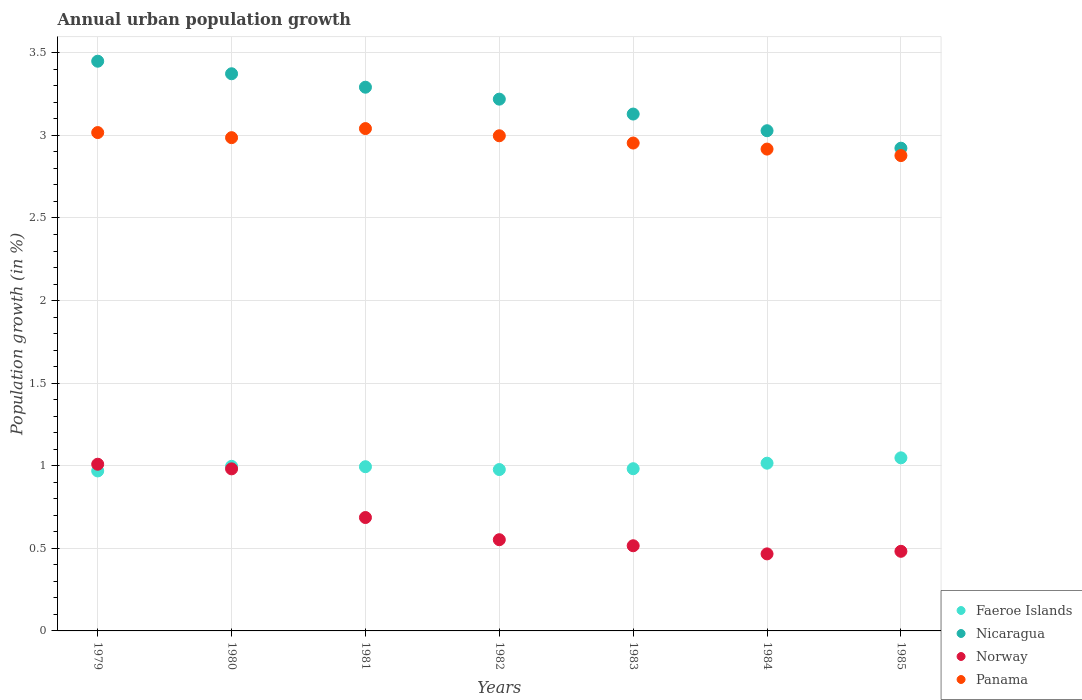What is the percentage of urban population growth in Faeroe Islands in 1979?
Your answer should be compact. 0.97. Across all years, what is the maximum percentage of urban population growth in Norway?
Your answer should be compact. 1.01. Across all years, what is the minimum percentage of urban population growth in Panama?
Offer a terse response. 2.88. In which year was the percentage of urban population growth in Norway minimum?
Provide a short and direct response. 1984. What is the total percentage of urban population growth in Faeroe Islands in the graph?
Keep it short and to the point. 6.98. What is the difference between the percentage of urban population growth in Norway in 1984 and that in 1985?
Your answer should be compact. -0.02. What is the difference between the percentage of urban population growth in Panama in 1985 and the percentage of urban population growth in Faeroe Islands in 1984?
Your answer should be compact. 1.86. What is the average percentage of urban population growth in Norway per year?
Keep it short and to the point. 0.67. In the year 1980, what is the difference between the percentage of urban population growth in Nicaragua and percentage of urban population growth in Panama?
Your answer should be very brief. 0.39. What is the ratio of the percentage of urban population growth in Panama in 1981 to that in 1983?
Provide a succinct answer. 1.03. What is the difference between the highest and the second highest percentage of urban population growth in Faeroe Islands?
Give a very brief answer. 0.03. What is the difference between the highest and the lowest percentage of urban population growth in Nicaragua?
Offer a very short reply. 0.53. Is it the case that in every year, the sum of the percentage of urban population growth in Faeroe Islands and percentage of urban population growth in Nicaragua  is greater than the percentage of urban population growth in Panama?
Your answer should be very brief. Yes. Does the percentage of urban population growth in Nicaragua monotonically increase over the years?
Keep it short and to the point. No. Is the percentage of urban population growth in Panama strictly less than the percentage of urban population growth in Faeroe Islands over the years?
Offer a very short reply. No. How many years are there in the graph?
Ensure brevity in your answer.  7. What is the difference between two consecutive major ticks on the Y-axis?
Offer a terse response. 0.5. Does the graph contain grids?
Offer a very short reply. Yes. Where does the legend appear in the graph?
Provide a succinct answer. Bottom right. How are the legend labels stacked?
Provide a short and direct response. Vertical. What is the title of the graph?
Offer a very short reply. Annual urban population growth. Does "Pakistan" appear as one of the legend labels in the graph?
Make the answer very short. No. What is the label or title of the Y-axis?
Make the answer very short. Population growth (in %). What is the Population growth (in %) of Faeroe Islands in 1979?
Offer a very short reply. 0.97. What is the Population growth (in %) of Nicaragua in 1979?
Your answer should be compact. 3.45. What is the Population growth (in %) in Norway in 1979?
Keep it short and to the point. 1.01. What is the Population growth (in %) of Panama in 1979?
Your answer should be very brief. 3.02. What is the Population growth (in %) of Faeroe Islands in 1980?
Provide a short and direct response. 1. What is the Population growth (in %) of Nicaragua in 1980?
Your answer should be compact. 3.37. What is the Population growth (in %) of Norway in 1980?
Provide a succinct answer. 0.98. What is the Population growth (in %) of Panama in 1980?
Ensure brevity in your answer.  2.99. What is the Population growth (in %) of Faeroe Islands in 1981?
Your answer should be very brief. 0.99. What is the Population growth (in %) of Nicaragua in 1981?
Your response must be concise. 3.29. What is the Population growth (in %) in Norway in 1981?
Provide a short and direct response. 0.69. What is the Population growth (in %) in Panama in 1981?
Your answer should be compact. 3.04. What is the Population growth (in %) in Faeroe Islands in 1982?
Your answer should be compact. 0.98. What is the Population growth (in %) of Nicaragua in 1982?
Make the answer very short. 3.22. What is the Population growth (in %) in Norway in 1982?
Your response must be concise. 0.55. What is the Population growth (in %) in Panama in 1982?
Offer a terse response. 3. What is the Population growth (in %) in Faeroe Islands in 1983?
Your answer should be very brief. 0.98. What is the Population growth (in %) in Nicaragua in 1983?
Offer a very short reply. 3.13. What is the Population growth (in %) in Norway in 1983?
Your response must be concise. 0.52. What is the Population growth (in %) in Panama in 1983?
Offer a terse response. 2.95. What is the Population growth (in %) of Faeroe Islands in 1984?
Offer a terse response. 1.02. What is the Population growth (in %) in Nicaragua in 1984?
Give a very brief answer. 3.03. What is the Population growth (in %) of Norway in 1984?
Your answer should be compact. 0.47. What is the Population growth (in %) in Panama in 1984?
Your response must be concise. 2.92. What is the Population growth (in %) in Faeroe Islands in 1985?
Provide a short and direct response. 1.05. What is the Population growth (in %) of Nicaragua in 1985?
Your answer should be very brief. 2.92. What is the Population growth (in %) of Norway in 1985?
Make the answer very short. 0.48. What is the Population growth (in %) in Panama in 1985?
Ensure brevity in your answer.  2.88. Across all years, what is the maximum Population growth (in %) of Faeroe Islands?
Keep it short and to the point. 1.05. Across all years, what is the maximum Population growth (in %) of Nicaragua?
Offer a terse response. 3.45. Across all years, what is the maximum Population growth (in %) of Norway?
Provide a succinct answer. 1.01. Across all years, what is the maximum Population growth (in %) of Panama?
Give a very brief answer. 3.04. Across all years, what is the minimum Population growth (in %) of Faeroe Islands?
Your answer should be very brief. 0.97. Across all years, what is the minimum Population growth (in %) in Nicaragua?
Ensure brevity in your answer.  2.92. Across all years, what is the minimum Population growth (in %) of Norway?
Give a very brief answer. 0.47. Across all years, what is the minimum Population growth (in %) of Panama?
Ensure brevity in your answer.  2.88. What is the total Population growth (in %) in Faeroe Islands in the graph?
Your answer should be very brief. 6.98. What is the total Population growth (in %) in Nicaragua in the graph?
Ensure brevity in your answer.  22.41. What is the total Population growth (in %) in Norway in the graph?
Give a very brief answer. 4.69. What is the total Population growth (in %) in Panama in the graph?
Offer a terse response. 20.79. What is the difference between the Population growth (in %) of Faeroe Islands in 1979 and that in 1980?
Provide a succinct answer. -0.03. What is the difference between the Population growth (in %) of Nicaragua in 1979 and that in 1980?
Ensure brevity in your answer.  0.08. What is the difference between the Population growth (in %) of Norway in 1979 and that in 1980?
Keep it short and to the point. 0.03. What is the difference between the Population growth (in %) in Panama in 1979 and that in 1980?
Offer a very short reply. 0.03. What is the difference between the Population growth (in %) in Faeroe Islands in 1979 and that in 1981?
Provide a short and direct response. -0.03. What is the difference between the Population growth (in %) of Nicaragua in 1979 and that in 1981?
Keep it short and to the point. 0.16. What is the difference between the Population growth (in %) of Norway in 1979 and that in 1981?
Ensure brevity in your answer.  0.32. What is the difference between the Population growth (in %) in Panama in 1979 and that in 1981?
Your answer should be very brief. -0.02. What is the difference between the Population growth (in %) in Faeroe Islands in 1979 and that in 1982?
Offer a very short reply. -0.01. What is the difference between the Population growth (in %) of Nicaragua in 1979 and that in 1982?
Your response must be concise. 0.23. What is the difference between the Population growth (in %) in Norway in 1979 and that in 1982?
Provide a succinct answer. 0.46. What is the difference between the Population growth (in %) of Panama in 1979 and that in 1982?
Keep it short and to the point. 0.02. What is the difference between the Population growth (in %) of Faeroe Islands in 1979 and that in 1983?
Provide a succinct answer. -0.01. What is the difference between the Population growth (in %) of Nicaragua in 1979 and that in 1983?
Ensure brevity in your answer.  0.32. What is the difference between the Population growth (in %) of Norway in 1979 and that in 1983?
Provide a short and direct response. 0.49. What is the difference between the Population growth (in %) in Panama in 1979 and that in 1983?
Ensure brevity in your answer.  0.06. What is the difference between the Population growth (in %) in Faeroe Islands in 1979 and that in 1984?
Offer a very short reply. -0.05. What is the difference between the Population growth (in %) of Nicaragua in 1979 and that in 1984?
Your answer should be very brief. 0.42. What is the difference between the Population growth (in %) of Norway in 1979 and that in 1984?
Your response must be concise. 0.54. What is the difference between the Population growth (in %) in Panama in 1979 and that in 1984?
Provide a short and direct response. 0.1. What is the difference between the Population growth (in %) in Faeroe Islands in 1979 and that in 1985?
Make the answer very short. -0.08. What is the difference between the Population growth (in %) of Nicaragua in 1979 and that in 1985?
Your answer should be compact. 0.53. What is the difference between the Population growth (in %) in Norway in 1979 and that in 1985?
Make the answer very short. 0.53. What is the difference between the Population growth (in %) of Panama in 1979 and that in 1985?
Provide a succinct answer. 0.14. What is the difference between the Population growth (in %) in Faeroe Islands in 1980 and that in 1981?
Your answer should be compact. 0. What is the difference between the Population growth (in %) of Nicaragua in 1980 and that in 1981?
Keep it short and to the point. 0.08. What is the difference between the Population growth (in %) in Norway in 1980 and that in 1981?
Provide a succinct answer. 0.29. What is the difference between the Population growth (in %) in Panama in 1980 and that in 1981?
Your answer should be very brief. -0.06. What is the difference between the Population growth (in %) in Faeroe Islands in 1980 and that in 1982?
Your answer should be very brief. 0.02. What is the difference between the Population growth (in %) in Nicaragua in 1980 and that in 1982?
Your answer should be very brief. 0.15. What is the difference between the Population growth (in %) of Norway in 1980 and that in 1982?
Keep it short and to the point. 0.43. What is the difference between the Population growth (in %) of Panama in 1980 and that in 1982?
Your response must be concise. -0.01. What is the difference between the Population growth (in %) in Faeroe Islands in 1980 and that in 1983?
Keep it short and to the point. 0.01. What is the difference between the Population growth (in %) in Nicaragua in 1980 and that in 1983?
Keep it short and to the point. 0.24. What is the difference between the Population growth (in %) in Norway in 1980 and that in 1983?
Your answer should be very brief. 0.47. What is the difference between the Population growth (in %) in Panama in 1980 and that in 1983?
Make the answer very short. 0.03. What is the difference between the Population growth (in %) of Faeroe Islands in 1980 and that in 1984?
Keep it short and to the point. -0.02. What is the difference between the Population growth (in %) in Nicaragua in 1980 and that in 1984?
Ensure brevity in your answer.  0.34. What is the difference between the Population growth (in %) in Norway in 1980 and that in 1984?
Your answer should be very brief. 0.51. What is the difference between the Population growth (in %) in Panama in 1980 and that in 1984?
Offer a terse response. 0.07. What is the difference between the Population growth (in %) in Faeroe Islands in 1980 and that in 1985?
Provide a succinct answer. -0.05. What is the difference between the Population growth (in %) of Nicaragua in 1980 and that in 1985?
Give a very brief answer. 0.45. What is the difference between the Population growth (in %) of Norway in 1980 and that in 1985?
Offer a very short reply. 0.5. What is the difference between the Population growth (in %) in Panama in 1980 and that in 1985?
Make the answer very short. 0.11. What is the difference between the Population growth (in %) in Faeroe Islands in 1981 and that in 1982?
Offer a terse response. 0.02. What is the difference between the Population growth (in %) in Nicaragua in 1981 and that in 1982?
Provide a short and direct response. 0.07. What is the difference between the Population growth (in %) of Norway in 1981 and that in 1982?
Offer a very short reply. 0.13. What is the difference between the Population growth (in %) of Panama in 1981 and that in 1982?
Provide a short and direct response. 0.04. What is the difference between the Population growth (in %) in Faeroe Islands in 1981 and that in 1983?
Offer a very short reply. 0.01. What is the difference between the Population growth (in %) in Nicaragua in 1981 and that in 1983?
Ensure brevity in your answer.  0.16. What is the difference between the Population growth (in %) in Norway in 1981 and that in 1983?
Keep it short and to the point. 0.17. What is the difference between the Population growth (in %) of Panama in 1981 and that in 1983?
Provide a short and direct response. 0.09. What is the difference between the Population growth (in %) in Faeroe Islands in 1981 and that in 1984?
Your response must be concise. -0.02. What is the difference between the Population growth (in %) of Nicaragua in 1981 and that in 1984?
Offer a very short reply. 0.26. What is the difference between the Population growth (in %) of Norway in 1981 and that in 1984?
Offer a terse response. 0.22. What is the difference between the Population growth (in %) of Panama in 1981 and that in 1984?
Provide a short and direct response. 0.12. What is the difference between the Population growth (in %) of Faeroe Islands in 1981 and that in 1985?
Your answer should be compact. -0.05. What is the difference between the Population growth (in %) in Nicaragua in 1981 and that in 1985?
Your answer should be compact. 0.37. What is the difference between the Population growth (in %) in Norway in 1981 and that in 1985?
Give a very brief answer. 0.2. What is the difference between the Population growth (in %) in Panama in 1981 and that in 1985?
Your answer should be compact. 0.16. What is the difference between the Population growth (in %) in Faeroe Islands in 1982 and that in 1983?
Your answer should be very brief. -0.01. What is the difference between the Population growth (in %) in Nicaragua in 1982 and that in 1983?
Offer a very short reply. 0.09. What is the difference between the Population growth (in %) of Norway in 1982 and that in 1983?
Ensure brevity in your answer.  0.04. What is the difference between the Population growth (in %) in Panama in 1982 and that in 1983?
Offer a very short reply. 0.04. What is the difference between the Population growth (in %) in Faeroe Islands in 1982 and that in 1984?
Provide a short and direct response. -0.04. What is the difference between the Population growth (in %) of Nicaragua in 1982 and that in 1984?
Offer a very short reply. 0.19. What is the difference between the Population growth (in %) in Norway in 1982 and that in 1984?
Offer a terse response. 0.09. What is the difference between the Population growth (in %) in Panama in 1982 and that in 1984?
Keep it short and to the point. 0.08. What is the difference between the Population growth (in %) in Faeroe Islands in 1982 and that in 1985?
Provide a succinct answer. -0.07. What is the difference between the Population growth (in %) in Nicaragua in 1982 and that in 1985?
Give a very brief answer. 0.3. What is the difference between the Population growth (in %) of Norway in 1982 and that in 1985?
Your response must be concise. 0.07. What is the difference between the Population growth (in %) in Panama in 1982 and that in 1985?
Your response must be concise. 0.12. What is the difference between the Population growth (in %) of Faeroe Islands in 1983 and that in 1984?
Give a very brief answer. -0.03. What is the difference between the Population growth (in %) of Nicaragua in 1983 and that in 1984?
Your response must be concise. 0.1. What is the difference between the Population growth (in %) of Norway in 1983 and that in 1984?
Offer a terse response. 0.05. What is the difference between the Population growth (in %) of Panama in 1983 and that in 1984?
Provide a succinct answer. 0.04. What is the difference between the Population growth (in %) of Faeroe Islands in 1983 and that in 1985?
Give a very brief answer. -0.07. What is the difference between the Population growth (in %) of Nicaragua in 1983 and that in 1985?
Ensure brevity in your answer.  0.21. What is the difference between the Population growth (in %) in Norway in 1983 and that in 1985?
Offer a terse response. 0.03. What is the difference between the Population growth (in %) in Panama in 1983 and that in 1985?
Provide a short and direct response. 0.08. What is the difference between the Population growth (in %) of Faeroe Islands in 1984 and that in 1985?
Your answer should be compact. -0.03. What is the difference between the Population growth (in %) in Nicaragua in 1984 and that in 1985?
Ensure brevity in your answer.  0.11. What is the difference between the Population growth (in %) in Norway in 1984 and that in 1985?
Your answer should be compact. -0.02. What is the difference between the Population growth (in %) in Panama in 1984 and that in 1985?
Provide a short and direct response. 0.04. What is the difference between the Population growth (in %) in Faeroe Islands in 1979 and the Population growth (in %) in Nicaragua in 1980?
Provide a succinct answer. -2.4. What is the difference between the Population growth (in %) in Faeroe Islands in 1979 and the Population growth (in %) in Norway in 1980?
Make the answer very short. -0.01. What is the difference between the Population growth (in %) of Faeroe Islands in 1979 and the Population growth (in %) of Panama in 1980?
Make the answer very short. -2.02. What is the difference between the Population growth (in %) of Nicaragua in 1979 and the Population growth (in %) of Norway in 1980?
Offer a terse response. 2.47. What is the difference between the Population growth (in %) of Nicaragua in 1979 and the Population growth (in %) of Panama in 1980?
Keep it short and to the point. 0.46. What is the difference between the Population growth (in %) in Norway in 1979 and the Population growth (in %) in Panama in 1980?
Give a very brief answer. -1.98. What is the difference between the Population growth (in %) of Faeroe Islands in 1979 and the Population growth (in %) of Nicaragua in 1981?
Your answer should be very brief. -2.32. What is the difference between the Population growth (in %) in Faeroe Islands in 1979 and the Population growth (in %) in Norway in 1981?
Ensure brevity in your answer.  0.28. What is the difference between the Population growth (in %) of Faeroe Islands in 1979 and the Population growth (in %) of Panama in 1981?
Provide a short and direct response. -2.07. What is the difference between the Population growth (in %) of Nicaragua in 1979 and the Population growth (in %) of Norway in 1981?
Give a very brief answer. 2.76. What is the difference between the Population growth (in %) of Nicaragua in 1979 and the Population growth (in %) of Panama in 1981?
Provide a succinct answer. 0.41. What is the difference between the Population growth (in %) in Norway in 1979 and the Population growth (in %) in Panama in 1981?
Your answer should be very brief. -2.03. What is the difference between the Population growth (in %) of Faeroe Islands in 1979 and the Population growth (in %) of Nicaragua in 1982?
Make the answer very short. -2.25. What is the difference between the Population growth (in %) in Faeroe Islands in 1979 and the Population growth (in %) in Norway in 1982?
Provide a succinct answer. 0.42. What is the difference between the Population growth (in %) of Faeroe Islands in 1979 and the Population growth (in %) of Panama in 1982?
Your response must be concise. -2.03. What is the difference between the Population growth (in %) in Nicaragua in 1979 and the Population growth (in %) in Norway in 1982?
Make the answer very short. 2.9. What is the difference between the Population growth (in %) of Nicaragua in 1979 and the Population growth (in %) of Panama in 1982?
Make the answer very short. 0.45. What is the difference between the Population growth (in %) of Norway in 1979 and the Population growth (in %) of Panama in 1982?
Your answer should be very brief. -1.99. What is the difference between the Population growth (in %) of Faeroe Islands in 1979 and the Population growth (in %) of Nicaragua in 1983?
Offer a terse response. -2.16. What is the difference between the Population growth (in %) of Faeroe Islands in 1979 and the Population growth (in %) of Norway in 1983?
Keep it short and to the point. 0.45. What is the difference between the Population growth (in %) in Faeroe Islands in 1979 and the Population growth (in %) in Panama in 1983?
Ensure brevity in your answer.  -1.99. What is the difference between the Population growth (in %) in Nicaragua in 1979 and the Population growth (in %) in Norway in 1983?
Offer a very short reply. 2.93. What is the difference between the Population growth (in %) of Nicaragua in 1979 and the Population growth (in %) of Panama in 1983?
Make the answer very short. 0.5. What is the difference between the Population growth (in %) of Norway in 1979 and the Population growth (in %) of Panama in 1983?
Provide a succinct answer. -1.94. What is the difference between the Population growth (in %) in Faeroe Islands in 1979 and the Population growth (in %) in Nicaragua in 1984?
Provide a succinct answer. -2.06. What is the difference between the Population growth (in %) of Faeroe Islands in 1979 and the Population growth (in %) of Norway in 1984?
Your answer should be very brief. 0.5. What is the difference between the Population growth (in %) in Faeroe Islands in 1979 and the Population growth (in %) in Panama in 1984?
Your answer should be very brief. -1.95. What is the difference between the Population growth (in %) of Nicaragua in 1979 and the Population growth (in %) of Norway in 1984?
Provide a short and direct response. 2.98. What is the difference between the Population growth (in %) in Nicaragua in 1979 and the Population growth (in %) in Panama in 1984?
Ensure brevity in your answer.  0.53. What is the difference between the Population growth (in %) in Norway in 1979 and the Population growth (in %) in Panama in 1984?
Your response must be concise. -1.91. What is the difference between the Population growth (in %) of Faeroe Islands in 1979 and the Population growth (in %) of Nicaragua in 1985?
Offer a very short reply. -1.95. What is the difference between the Population growth (in %) of Faeroe Islands in 1979 and the Population growth (in %) of Norway in 1985?
Provide a succinct answer. 0.49. What is the difference between the Population growth (in %) of Faeroe Islands in 1979 and the Population growth (in %) of Panama in 1985?
Ensure brevity in your answer.  -1.91. What is the difference between the Population growth (in %) of Nicaragua in 1979 and the Population growth (in %) of Norway in 1985?
Provide a succinct answer. 2.97. What is the difference between the Population growth (in %) in Nicaragua in 1979 and the Population growth (in %) in Panama in 1985?
Give a very brief answer. 0.57. What is the difference between the Population growth (in %) of Norway in 1979 and the Population growth (in %) of Panama in 1985?
Your answer should be compact. -1.87. What is the difference between the Population growth (in %) in Faeroe Islands in 1980 and the Population growth (in %) in Nicaragua in 1981?
Give a very brief answer. -2.3. What is the difference between the Population growth (in %) in Faeroe Islands in 1980 and the Population growth (in %) in Norway in 1981?
Your response must be concise. 0.31. What is the difference between the Population growth (in %) in Faeroe Islands in 1980 and the Population growth (in %) in Panama in 1981?
Your answer should be compact. -2.04. What is the difference between the Population growth (in %) of Nicaragua in 1980 and the Population growth (in %) of Norway in 1981?
Your answer should be very brief. 2.69. What is the difference between the Population growth (in %) of Nicaragua in 1980 and the Population growth (in %) of Panama in 1981?
Keep it short and to the point. 0.33. What is the difference between the Population growth (in %) of Norway in 1980 and the Population growth (in %) of Panama in 1981?
Your response must be concise. -2.06. What is the difference between the Population growth (in %) in Faeroe Islands in 1980 and the Population growth (in %) in Nicaragua in 1982?
Your response must be concise. -2.22. What is the difference between the Population growth (in %) of Faeroe Islands in 1980 and the Population growth (in %) of Norway in 1982?
Keep it short and to the point. 0.44. What is the difference between the Population growth (in %) in Faeroe Islands in 1980 and the Population growth (in %) in Panama in 1982?
Your answer should be compact. -2. What is the difference between the Population growth (in %) in Nicaragua in 1980 and the Population growth (in %) in Norway in 1982?
Offer a very short reply. 2.82. What is the difference between the Population growth (in %) of Nicaragua in 1980 and the Population growth (in %) of Panama in 1982?
Provide a succinct answer. 0.38. What is the difference between the Population growth (in %) in Norway in 1980 and the Population growth (in %) in Panama in 1982?
Keep it short and to the point. -2.02. What is the difference between the Population growth (in %) in Faeroe Islands in 1980 and the Population growth (in %) in Nicaragua in 1983?
Give a very brief answer. -2.13. What is the difference between the Population growth (in %) of Faeroe Islands in 1980 and the Population growth (in %) of Norway in 1983?
Provide a succinct answer. 0.48. What is the difference between the Population growth (in %) of Faeroe Islands in 1980 and the Population growth (in %) of Panama in 1983?
Provide a short and direct response. -1.96. What is the difference between the Population growth (in %) in Nicaragua in 1980 and the Population growth (in %) in Norway in 1983?
Ensure brevity in your answer.  2.86. What is the difference between the Population growth (in %) of Nicaragua in 1980 and the Population growth (in %) of Panama in 1983?
Your answer should be very brief. 0.42. What is the difference between the Population growth (in %) of Norway in 1980 and the Population growth (in %) of Panama in 1983?
Provide a succinct answer. -1.97. What is the difference between the Population growth (in %) of Faeroe Islands in 1980 and the Population growth (in %) of Nicaragua in 1984?
Keep it short and to the point. -2.03. What is the difference between the Population growth (in %) of Faeroe Islands in 1980 and the Population growth (in %) of Norway in 1984?
Provide a short and direct response. 0.53. What is the difference between the Population growth (in %) in Faeroe Islands in 1980 and the Population growth (in %) in Panama in 1984?
Provide a succinct answer. -1.92. What is the difference between the Population growth (in %) in Nicaragua in 1980 and the Population growth (in %) in Norway in 1984?
Offer a very short reply. 2.91. What is the difference between the Population growth (in %) of Nicaragua in 1980 and the Population growth (in %) of Panama in 1984?
Keep it short and to the point. 0.46. What is the difference between the Population growth (in %) of Norway in 1980 and the Population growth (in %) of Panama in 1984?
Offer a very short reply. -1.94. What is the difference between the Population growth (in %) of Faeroe Islands in 1980 and the Population growth (in %) of Nicaragua in 1985?
Your answer should be very brief. -1.93. What is the difference between the Population growth (in %) in Faeroe Islands in 1980 and the Population growth (in %) in Norway in 1985?
Ensure brevity in your answer.  0.51. What is the difference between the Population growth (in %) of Faeroe Islands in 1980 and the Population growth (in %) of Panama in 1985?
Your answer should be very brief. -1.88. What is the difference between the Population growth (in %) of Nicaragua in 1980 and the Population growth (in %) of Norway in 1985?
Provide a succinct answer. 2.89. What is the difference between the Population growth (in %) of Nicaragua in 1980 and the Population growth (in %) of Panama in 1985?
Your answer should be very brief. 0.5. What is the difference between the Population growth (in %) of Norway in 1980 and the Population growth (in %) of Panama in 1985?
Offer a very short reply. -1.9. What is the difference between the Population growth (in %) of Faeroe Islands in 1981 and the Population growth (in %) of Nicaragua in 1982?
Provide a short and direct response. -2.23. What is the difference between the Population growth (in %) of Faeroe Islands in 1981 and the Population growth (in %) of Norway in 1982?
Keep it short and to the point. 0.44. What is the difference between the Population growth (in %) of Faeroe Islands in 1981 and the Population growth (in %) of Panama in 1982?
Offer a terse response. -2. What is the difference between the Population growth (in %) of Nicaragua in 1981 and the Population growth (in %) of Norway in 1982?
Keep it short and to the point. 2.74. What is the difference between the Population growth (in %) in Nicaragua in 1981 and the Population growth (in %) in Panama in 1982?
Your answer should be very brief. 0.29. What is the difference between the Population growth (in %) of Norway in 1981 and the Population growth (in %) of Panama in 1982?
Your response must be concise. -2.31. What is the difference between the Population growth (in %) in Faeroe Islands in 1981 and the Population growth (in %) in Nicaragua in 1983?
Give a very brief answer. -2.13. What is the difference between the Population growth (in %) of Faeroe Islands in 1981 and the Population growth (in %) of Norway in 1983?
Make the answer very short. 0.48. What is the difference between the Population growth (in %) of Faeroe Islands in 1981 and the Population growth (in %) of Panama in 1983?
Provide a succinct answer. -1.96. What is the difference between the Population growth (in %) in Nicaragua in 1981 and the Population growth (in %) in Norway in 1983?
Provide a short and direct response. 2.78. What is the difference between the Population growth (in %) in Nicaragua in 1981 and the Population growth (in %) in Panama in 1983?
Your answer should be very brief. 0.34. What is the difference between the Population growth (in %) in Norway in 1981 and the Population growth (in %) in Panama in 1983?
Offer a terse response. -2.27. What is the difference between the Population growth (in %) in Faeroe Islands in 1981 and the Population growth (in %) in Nicaragua in 1984?
Offer a terse response. -2.03. What is the difference between the Population growth (in %) in Faeroe Islands in 1981 and the Population growth (in %) in Norway in 1984?
Provide a succinct answer. 0.53. What is the difference between the Population growth (in %) in Faeroe Islands in 1981 and the Population growth (in %) in Panama in 1984?
Keep it short and to the point. -1.92. What is the difference between the Population growth (in %) of Nicaragua in 1981 and the Population growth (in %) of Norway in 1984?
Make the answer very short. 2.83. What is the difference between the Population growth (in %) in Nicaragua in 1981 and the Population growth (in %) in Panama in 1984?
Give a very brief answer. 0.37. What is the difference between the Population growth (in %) in Norway in 1981 and the Population growth (in %) in Panama in 1984?
Provide a succinct answer. -2.23. What is the difference between the Population growth (in %) in Faeroe Islands in 1981 and the Population growth (in %) in Nicaragua in 1985?
Offer a very short reply. -1.93. What is the difference between the Population growth (in %) of Faeroe Islands in 1981 and the Population growth (in %) of Norway in 1985?
Offer a very short reply. 0.51. What is the difference between the Population growth (in %) in Faeroe Islands in 1981 and the Population growth (in %) in Panama in 1985?
Offer a terse response. -1.88. What is the difference between the Population growth (in %) in Nicaragua in 1981 and the Population growth (in %) in Norway in 1985?
Make the answer very short. 2.81. What is the difference between the Population growth (in %) in Nicaragua in 1981 and the Population growth (in %) in Panama in 1985?
Offer a terse response. 0.41. What is the difference between the Population growth (in %) in Norway in 1981 and the Population growth (in %) in Panama in 1985?
Provide a short and direct response. -2.19. What is the difference between the Population growth (in %) of Faeroe Islands in 1982 and the Population growth (in %) of Nicaragua in 1983?
Offer a very short reply. -2.15. What is the difference between the Population growth (in %) in Faeroe Islands in 1982 and the Population growth (in %) in Norway in 1983?
Make the answer very short. 0.46. What is the difference between the Population growth (in %) in Faeroe Islands in 1982 and the Population growth (in %) in Panama in 1983?
Your response must be concise. -1.98. What is the difference between the Population growth (in %) in Nicaragua in 1982 and the Population growth (in %) in Norway in 1983?
Make the answer very short. 2.7. What is the difference between the Population growth (in %) in Nicaragua in 1982 and the Population growth (in %) in Panama in 1983?
Your response must be concise. 0.27. What is the difference between the Population growth (in %) in Norway in 1982 and the Population growth (in %) in Panama in 1983?
Your response must be concise. -2.4. What is the difference between the Population growth (in %) in Faeroe Islands in 1982 and the Population growth (in %) in Nicaragua in 1984?
Your answer should be compact. -2.05. What is the difference between the Population growth (in %) in Faeroe Islands in 1982 and the Population growth (in %) in Norway in 1984?
Offer a terse response. 0.51. What is the difference between the Population growth (in %) in Faeroe Islands in 1982 and the Population growth (in %) in Panama in 1984?
Your response must be concise. -1.94. What is the difference between the Population growth (in %) of Nicaragua in 1982 and the Population growth (in %) of Norway in 1984?
Offer a terse response. 2.75. What is the difference between the Population growth (in %) in Nicaragua in 1982 and the Population growth (in %) in Panama in 1984?
Your response must be concise. 0.3. What is the difference between the Population growth (in %) in Norway in 1982 and the Population growth (in %) in Panama in 1984?
Make the answer very short. -2.36. What is the difference between the Population growth (in %) of Faeroe Islands in 1982 and the Population growth (in %) of Nicaragua in 1985?
Ensure brevity in your answer.  -1.95. What is the difference between the Population growth (in %) in Faeroe Islands in 1982 and the Population growth (in %) in Norway in 1985?
Your response must be concise. 0.49. What is the difference between the Population growth (in %) in Faeroe Islands in 1982 and the Population growth (in %) in Panama in 1985?
Give a very brief answer. -1.9. What is the difference between the Population growth (in %) of Nicaragua in 1982 and the Population growth (in %) of Norway in 1985?
Give a very brief answer. 2.74. What is the difference between the Population growth (in %) in Nicaragua in 1982 and the Population growth (in %) in Panama in 1985?
Your answer should be compact. 0.34. What is the difference between the Population growth (in %) of Norway in 1982 and the Population growth (in %) of Panama in 1985?
Ensure brevity in your answer.  -2.33. What is the difference between the Population growth (in %) in Faeroe Islands in 1983 and the Population growth (in %) in Nicaragua in 1984?
Make the answer very short. -2.05. What is the difference between the Population growth (in %) in Faeroe Islands in 1983 and the Population growth (in %) in Norway in 1984?
Keep it short and to the point. 0.52. What is the difference between the Population growth (in %) in Faeroe Islands in 1983 and the Population growth (in %) in Panama in 1984?
Your answer should be very brief. -1.94. What is the difference between the Population growth (in %) in Nicaragua in 1983 and the Population growth (in %) in Norway in 1984?
Provide a short and direct response. 2.66. What is the difference between the Population growth (in %) of Nicaragua in 1983 and the Population growth (in %) of Panama in 1984?
Your answer should be compact. 0.21. What is the difference between the Population growth (in %) of Norway in 1983 and the Population growth (in %) of Panama in 1984?
Your response must be concise. -2.4. What is the difference between the Population growth (in %) in Faeroe Islands in 1983 and the Population growth (in %) in Nicaragua in 1985?
Provide a succinct answer. -1.94. What is the difference between the Population growth (in %) in Faeroe Islands in 1983 and the Population growth (in %) in Norway in 1985?
Provide a short and direct response. 0.5. What is the difference between the Population growth (in %) in Faeroe Islands in 1983 and the Population growth (in %) in Panama in 1985?
Offer a terse response. -1.9. What is the difference between the Population growth (in %) of Nicaragua in 1983 and the Population growth (in %) of Norway in 1985?
Your response must be concise. 2.65. What is the difference between the Population growth (in %) in Nicaragua in 1983 and the Population growth (in %) in Panama in 1985?
Offer a very short reply. 0.25. What is the difference between the Population growth (in %) in Norway in 1983 and the Population growth (in %) in Panama in 1985?
Make the answer very short. -2.36. What is the difference between the Population growth (in %) in Faeroe Islands in 1984 and the Population growth (in %) in Nicaragua in 1985?
Keep it short and to the point. -1.91. What is the difference between the Population growth (in %) in Faeroe Islands in 1984 and the Population growth (in %) in Norway in 1985?
Your answer should be very brief. 0.53. What is the difference between the Population growth (in %) in Faeroe Islands in 1984 and the Population growth (in %) in Panama in 1985?
Keep it short and to the point. -1.86. What is the difference between the Population growth (in %) in Nicaragua in 1984 and the Population growth (in %) in Norway in 1985?
Your answer should be compact. 2.55. What is the difference between the Population growth (in %) in Nicaragua in 1984 and the Population growth (in %) in Panama in 1985?
Offer a terse response. 0.15. What is the difference between the Population growth (in %) of Norway in 1984 and the Population growth (in %) of Panama in 1985?
Make the answer very short. -2.41. What is the average Population growth (in %) in Faeroe Islands per year?
Keep it short and to the point. 1. What is the average Population growth (in %) in Nicaragua per year?
Make the answer very short. 3.2. What is the average Population growth (in %) in Norway per year?
Provide a short and direct response. 0.67. What is the average Population growth (in %) in Panama per year?
Ensure brevity in your answer.  2.97. In the year 1979, what is the difference between the Population growth (in %) in Faeroe Islands and Population growth (in %) in Nicaragua?
Provide a short and direct response. -2.48. In the year 1979, what is the difference between the Population growth (in %) of Faeroe Islands and Population growth (in %) of Norway?
Offer a terse response. -0.04. In the year 1979, what is the difference between the Population growth (in %) of Faeroe Islands and Population growth (in %) of Panama?
Offer a very short reply. -2.05. In the year 1979, what is the difference between the Population growth (in %) in Nicaragua and Population growth (in %) in Norway?
Your response must be concise. 2.44. In the year 1979, what is the difference between the Population growth (in %) in Nicaragua and Population growth (in %) in Panama?
Offer a terse response. 0.43. In the year 1979, what is the difference between the Population growth (in %) of Norway and Population growth (in %) of Panama?
Your answer should be compact. -2.01. In the year 1980, what is the difference between the Population growth (in %) of Faeroe Islands and Population growth (in %) of Nicaragua?
Your answer should be compact. -2.38. In the year 1980, what is the difference between the Population growth (in %) of Faeroe Islands and Population growth (in %) of Norway?
Provide a succinct answer. 0.02. In the year 1980, what is the difference between the Population growth (in %) in Faeroe Islands and Population growth (in %) in Panama?
Offer a very short reply. -1.99. In the year 1980, what is the difference between the Population growth (in %) in Nicaragua and Population growth (in %) in Norway?
Your response must be concise. 2.39. In the year 1980, what is the difference between the Population growth (in %) in Nicaragua and Population growth (in %) in Panama?
Offer a terse response. 0.39. In the year 1980, what is the difference between the Population growth (in %) of Norway and Population growth (in %) of Panama?
Your response must be concise. -2. In the year 1981, what is the difference between the Population growth (in %) of Faeroe Islands and Population growth (in %) of Nicaragua?
Your answer should be compact. -2.3. In the year 1981, what is the difference between the Population growth (in %) in Faeroe Islands and Population growth (in %) in Norway?
Give a very brief answer. 0.31. In the year 1981, what is the difference between the Population growth (in %) of Faeroe Islands and Population growth (in %) of Panama?
Provide a short and direct response. -2.05. In the year 1981, what is the difference between the Population growth (in %) in Nicaragua and Population growth (in %) in Norway?
Provide a short and direct response. 2.61. In the year 1981, what is the difference between the Population growth (in %) of Nicaragua and Population growth (in %) of Panama?
Offer a terse response. 0.25. In the year 1981, what is the difference between the Population growth (in %) in Norway and Population growth (in %) in Panama?
Offer a terse response. -2.35. In the year 1982, what is the difference between the Population growth (in %) of Faeroe Islands and Population growth (in %) of Nicaragua?
Ensure brevity in your answer.  -2.24. In the year 1982, what is the difference between the Population growth (in %) in Faeroe Islands and Population growth (in %) in Norway?
Give a very brief answer. 0.42. In the year 1982, what is the difference between the Population growth (in %) in Faeroe Islands and Population growth (in %) in Panama?
Offer a terse response. -2.02. In the year 1982, what is the difference between the Population growth (in %) of Nicaragua and Population growth (in %) of Norway?
Your answer should be compact. 2.67. In the year 1982, what is the difference between the Population growth (in %) of Nicaragua and Population growth (in %) of Panama?
Provide a succinct answer. 0.22. In the year 1982, what is the difference between the Population growth (in %) of Norway and Population growth (in %) of Panama?
Your answer should be very brief. -2.45. In the year 1983, what is the difference between the Population growth (in %) in Faeroe Islands and Population growth (in %) in Nicaragua?
Your answer should be compact. -2.15. In the year 1983, what is the difference between the Population growth (in %) in Faeroe Islands and Population growth (in %) in Norway?
Keep it short and to the point. 0.47. In the year 1983, what is the difference between the Population growth (in %) in Faeroe Islands and Population growth (in %) in Panama?
Provide a succinct answer. -1.97. In the year 1983, what is the difference between the Population growth (in %) of Nicaragua and Population growth (in %) of Norway?
Provide a short and direct response. 2.61. In the year 1983, what is the difference between the Population growth (in %) in Nicaragua and Population growth (in %) in Panama?
Your response must be concise. 0.18. In the year 1983, what is the difference between the Population growth (in %) of Norway and Population growth (in %) of Panama?
Provide a succinct answer. -2.44. In the year 1984, what is the difference between the Population growth (in %) in Faeroe Islands and Population growth (in %) in Nicaragua?
Give a very brief answer. -2.01. In the year 1984, what is the difference between the Population growth (in %) of Faeroe Islands and Population growth (in %) of Norway?
Your answer should be very brief. 0.55. In the year 1984, what is the difference between the Population growth (in %) of Faeroe Islands and Population growth (in %) of Panama?
Provide a short and direct response. -1.9. In the year 1984, what is the difference between the Population growth (in %) in Nicaragua and Population growth (in %) in Norway?
Your answer should be very brief. 2.56. In the year 1984, what is the difference between the Population growth (in %) of Nicaragua and Population growth (in %) of Panama?
Your answer should be very brief. 0.11. In the year 1984, what is the difference between the Population growth (in %) in Norway and Population growth (in %) in Panama?
Give a very brief answer. -2.45. In the year 1985, what is the difference between the Population growth (in %) of Faeroe Islands and Population growth (in %) of Nicaragua?
Offer a terse response. -1.87. In the year 1985, what is the difference between the Population growth (in %) in Faeroe Islands and Population growth (in %) in Norway?
Offer a very short reply. 0.57. In the year 1985, what is the difference between the Population growth (in %) in Faeroe Islands and Population growth (in %) in Panama?
Keep it short and to the point. -1.83. In the year 1985, what is the difference between the Population growth (in %) of Nicaragua and Population growth (in %) of Norway?
Offer a very short reply. 2.44. In the year 1985, what is the difference between the Population growth (in %) in Nicaragua and Population growth (in %) in Panama?
Provide a short and direct response. 0.04. In the year 1985, what is the difference between the Population growth (in %) in Norway and Population growth (in %) in Panama?
Your response must be concise. -2.4. What is the ratio of the Population growth (in %) in Faeroe Islands in 1979 to that in 1980?
Give a very brief answer. 0.97. What is the ratio of the Population growth (in %) in Nicaragua in 1979 to that in 1980?
Give a very brief answer. 1.02. What is the ratio of the Population growth (in %) in Norway in 1979 to that in 1980?
Your answer should be very brief. 1.03. What is the ratio of the Population growth (in %) in Panama in 1979 to that in 1980?
Provide a succinct answer. 1.01. What is the ratio of the Population growth (in %) of Faeroe Islands in 1979 to that in 1981?
Ensure brevity in your answer.  0.97. What is the ratio of the Population growth (in %) of Nicaragua in 1979 to that in 1981?
Keep it short and to the point. 1.05. What is the ratio of the Population growth (in %) in Norway in 1979 to that in 1981?
Ensure brevity in your answer.  1.47. What is the ratio of the Population growth (in %) in Nicaragua in 1979 to that in 1982?
Your response must be concise. 1.07. What is the ratio of the Population growth (in %) of Norway in 1979 to that in 1982?
Ensure brevity in your answer.  1.83. What is the ratio of the Population growth (in %) in Panama in 1979 to that in 1982?
Offer a very short reply. 1.01. What is the ratio of the Population growth (in %) in Faeroe Islands in 1979 to that in 1983?
Offer a terse response. 0.99. What is the ratio of the Population growth (in %) in Nicaragua in 1979 to that in 1983?
Keep it short and to the point. 1.1. What is the ratio of the Population growth (in %) in Norway in 1979 to that in 1983?
Ensure brevity in your answer.  1.96. What is the ratio of the Population growth (in %) of Panama in 1979 to that in 1983?
Offer a very short reply. 1.02. What is the ratio of the Population growth (in %) of Faeroe Islands in 1979 to that in 1984?
Offer a very short reply. 0.95. What is the ratio of the Population growth (in %) in Nicaragua in 1979 to that in 1984?
Your response must be concise. 1.14. What is the ratio of the Population growth (in %) of Norway in 1979 to that in 1984?
Your answer should be very brief. 2.16. What is the ratio of the Population growth (in %) in Panama in 1979 to that in 1984?
Your response must be concise. 1.03. What is the ratio of the Population growth (in %) in Faeroe Islands in 1979 to that in 1985?
Provide a succinct answer. 0.92. What is the ratio of the Population growth (in %) of Nicaragua in 1979 to that in 1985?
Keep it short and to the point. 1.18. What is the ratio of the Population growth (in %) of Norway in 1979 to that in 1985?
Provide a succinct answer. 2.09. What is the ratio of the Population growth (in %) in Panama in 1979 to that in 1985?
Your answer should be compact. 1.05. What is the ratio of the Population growth (in %) of Nicaragua in 1980 to that in 1981?
Provide a short and direct response. 1.02. What is the ratio of the Population growth (in %) in Norway in 1980 to that in 1981?
Offer a very short reply. 1.43. What is the ratio of the Population growth (in %) in Panama in 1980 to that in 1981?
Your answer should be very brief. 0.98. What is the ratio of the Population growth (in %) of Faeroe Islands in 1980 to that in 1982?
Your answer should be very brief. 1.02. What is the ratio of the Population growth (in %) of Nicaragua in 1980 to that in 1982?
Give a very brief answer. 1.05. What is the ratio of the Population growth (in %) of Norway in 1980 to that in 1982?
Provide a succinct answer. 1.78. What is the ratio of the Population growth (in %) in Panama in 1980 to that in 1982?
Provide a short and direct response. 1. What is the ratio of the Population growth (in %) in Faeroe Islands in 1980 to that in 1983?
Offer a very short reply. 1.01. What is the ratio of the Population growth (in %) in Nicaragua in 1980 to that in 1983?
Your response must be concise. 1.08. What is the ratio of the Population growth (in %) in Norway in 1980 to that in 1983?
Your answer should be compact. 1.9. What is the ratio of the Population growth (in %) in Faeroe Islands in 1980 to that in 1984?
Keep it short and to the point. 0.98. What is the ratio of the Population growth (in %) of Nicaragua in 1980 to that in 1984?
Your answer should be compact. 1.11. What is the ratio of the Population growth (in %) of Norway in 1980 to that in 1984?
Your response must be concise. 2.1. What is the ratio of the Population growth (in %) in Panama in 1980 to that in 1984?
Make the answer very short. 1.02. What is the ratio of the Population growth (in %) of Faeroe Islands in 1980 to that in 1985?
Make the answer very short. 0.95. What is the ratio of the Population growth (in %) of Nicaragua in 1980 to that in 1985?
Keep it short and to the point. 1.15. What is the ratio of the Population growth (in %) in Norway in 1980 to that in 1985?
Your answer should be compact. 2.04. What is the ratio of the Population growth (in %) in Panama in 1980 to that in 1985?
Your answer should be compact. 1.04. What is the ratio of the Population growth (in %) of Faeroe Islands in 1981 to that in 1982?
Your answer should be very brief. 1.02. What is the ratio of the Population growth (in %) in Nicaragua in 1981 to that in 1982?
Your response must be concise. 1.02. What is the ratio of the Population growth (in %) of Norway in 1981 to that in 1982?
Provide a succinct answer. 1.24. What is the ratio of the Population growth (in %) of Panama in 1981 to that in 1982?
Provide a short and direct response. 1.01. What is the ratio of the Population growth (in %) in Faeroe Islands in 1981 to that in 1983?
Your answer should be compact. 1.01. What is the ratio of the Population growth (in %) in Nicaragua in 1981 to that in 1983?
Make the answer very short. 1.05. What is the ratio of the Population growth (in %) in Norway in 1981 to that in 1983?
Ensure brevity in your answer.  1.33. What is the ratio of the Population growth (in %) in Panama in 1981 to that in 1983?
Ensure brevity in your answer.  1.03. What is the ratio of the Population growth (in %) in Faeroe Islands in 1981 to that in 1984?
Offer a very short reply. 0.98. What is the ratio of the Population growth (in %) of Nicaragua in 1981 to that in 1984?
Offer a terse response. 1.09. What is the ratio of the Population growth (in %) in Norway in 1981 to that in 1984?
Give a very brief answer. 1.47. What is the ratio of the Population growth (in %) of Panama in 1981 to that in 1984?
Your answer should be very brief. 1.04. What is the ratio of the Population growth (in %) in Faeroe Islands in 1981 to that in 1985?
Keep it short and to the point. 0.95. What is the ratio of the Population growth (in %) of Nicaragua in 1981 to that in 1985?
Offer a terse response. 1.13. What is the ratio of the Population growth (in %) in Norway in 1981 to that in 1985?
Ensure brevity in your answer.  1.42. What is the ratio of the Population growth (in %) in Panama in 1981 to that in 1985?
Your answer should be very brief. 1.06. What is the ratio of the Population growth (in %) in Nicaragua in 1982 to that in 1983?
Provide a succinct answer. 1.03. What is the ratio of the Population growth (in %) in Norway in 1982 to that in 1983?
Keep it short and to the point. 1.07. What is the ratio of the Population growth (in %) of Panama in 1982 to that in 1983?
Your answer should be compact. 1.01. What is the ratio of the Population growth (in %) of Faeroe Islands in 1982 to that in 1984?
Offer a very short reply. 0.96. What is the ratio of the Population growth (in %) in Nicaragua in 1982 to that in 1984?
Give a very brief answer. 1.06. What is the ratio of the Population growth (in %) in Norway in 1982 to that in 1984?
Make the answer very short. 1.18. What is the ratio of the Population growth (in %) of Panama in 1982 to that in 1984?
Your response must be concise. 1.03. What is the ratio of the Population growth (in %) in Faeroe Islands in 1982 to that in 1985?
Offer a very short reply. 0.93. What is the ratio of the Population growth (in %) in Nicaragua in 1982 to that in 1985?
Your response must be concise. 1.1. What is the ratio of the Population growth (in %) in Norway in 1982 to that in 1985?
Ensure brevity in your answer.  1.15. What is the ratio of the Population growth (in %) in Panama in 1982 to that in 1985?
Provide a succinct answer. 1.04. What is the ratio of the Population growth (in %) in Faeroe Islands in 1983 to that in 1984?
Ensure brevity in your answer.  0.97. What is the ratio of the Population growth (in %) in Norway in 1983 to that in 1984?
Offer a terse response. 1.11. What is the ratio of the Population growth (in %) of Panama in 1983 to that in 1984?
Provide a succinct answer. 1.01. What is the ratio of the Population growth (in %) in Faeroe Islands in 1983 to that in 1985?
Your response must be concise. 0.94. What is the ratio of the Population growth (in %) in Nicaragua in 1983 to that in 1985?
Provide a succinct answer. 1.07. What is the ratio of the Population growth (in %) of Norway in 1983 to that in 1985?
Make the answer very short. 1.07. What is the ratio of the Population growth (in %) in Panama in 1983 to that in 1985?
Your response must be concise. 1.03. What is the ratio of the Population growth (in %) in Faeroe Islands in 1984 to that in 1985?
Keep it short and to the point. 0.97. What is the ratio of the Population growth (in %) in Nicaragua in 1984 to that in 1985?
Give a very brief answer. 1.04. What is the ratio of the Population growth (in %) of Norway in 1984 to that in 1985?
Provide a short and direct response. 0.97. What is the ratio of the Population growth (in %) in Panama in 1984 to that in 1985?
Offer a very short reply. 1.01. What is the difference between the highest and the second highest Population growth (in %) of Faeroe Islands?
Provide a short and direct response. 0.03. What is the difference between the highest and the second highest Population growth (in %) of Nicaragua?
Provide a short and direct response. 0.08. What is the difference between the highest and the second highest Population growth (in %) of Norway?
Provide a short and direct response. 0.03. What is the difference between the highest and the second highest Population growth (in %) in Panama?
Your answer should be compact. 0.02. What is the difference between the highest and the lowest Population growth (in %) in Faeroe Islands?
Give a very brief answer. 0.08. What is the difference between the highest and the lowest Population growth (in %) of Nicaragua?
Keep it short and to the point. 0.53. What is the difference between the highest and the lowest Population growth (in %) of Norway?
Give a very brief answer. 0.54. What is the difference between the highest and the lowest Population growth (in %) in Panama?
Offer a terse response. 0.16. 